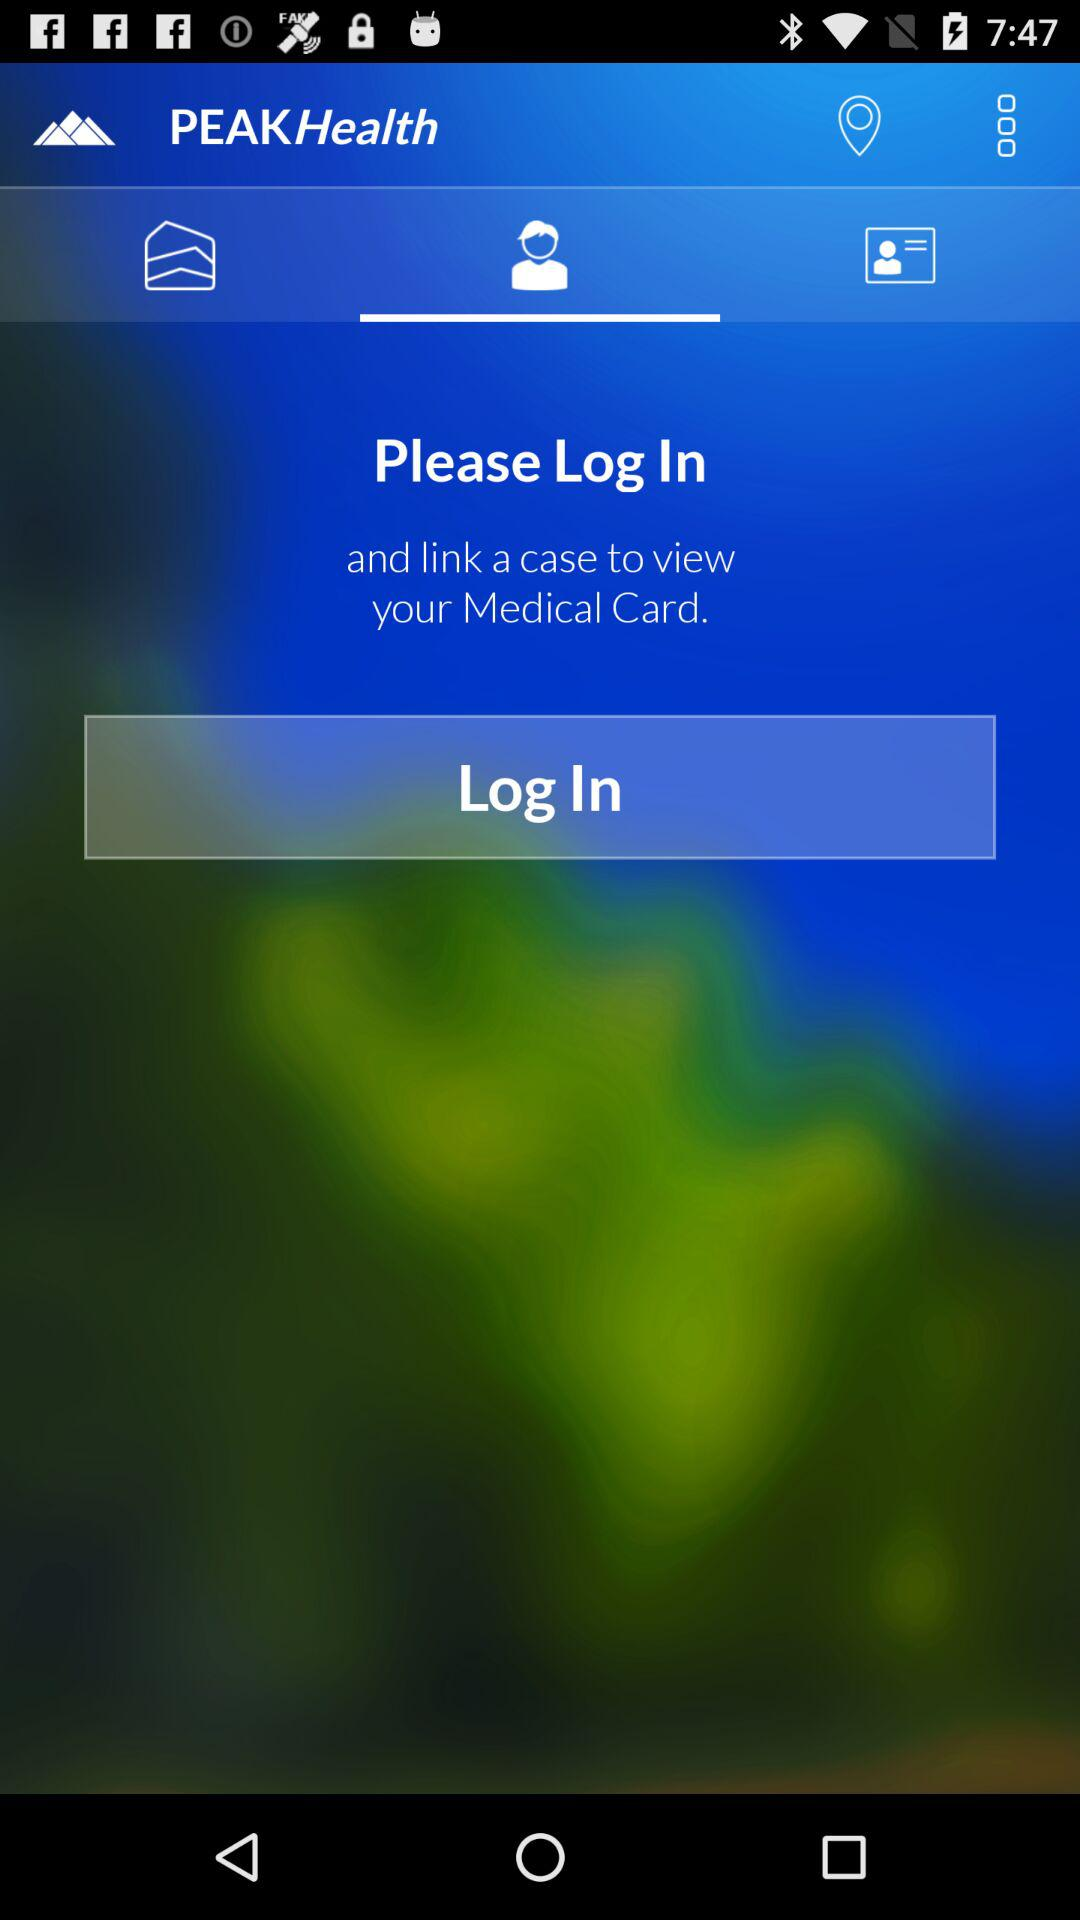What is the app name? The app name is "PeakHealth". 